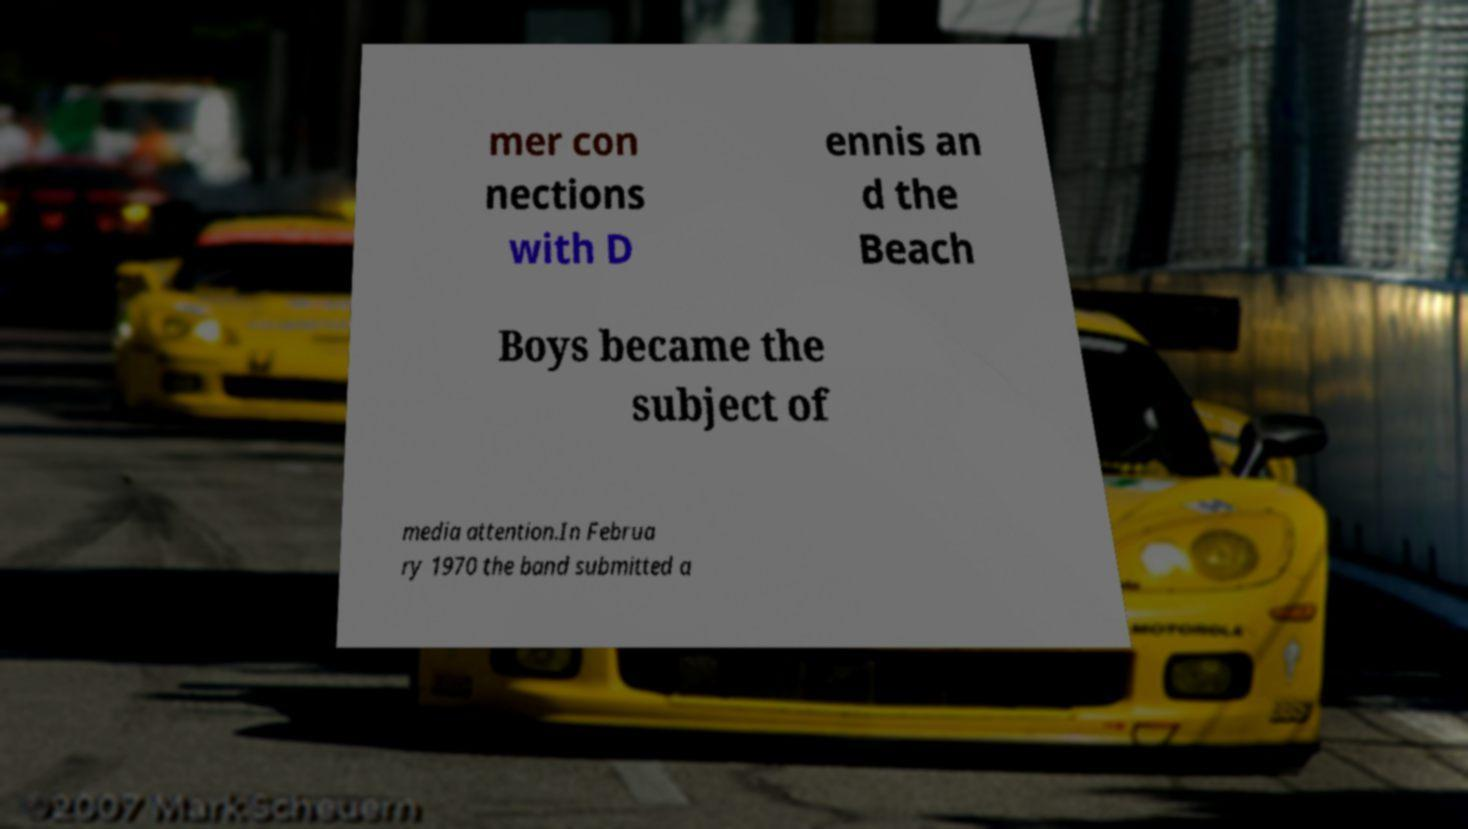Can you accurately transcribe the text from the provided image for me? mer con nections with D ennis an d the Beach Boys became the subject of media attention.In Februa ry 1970 the band submitted a 